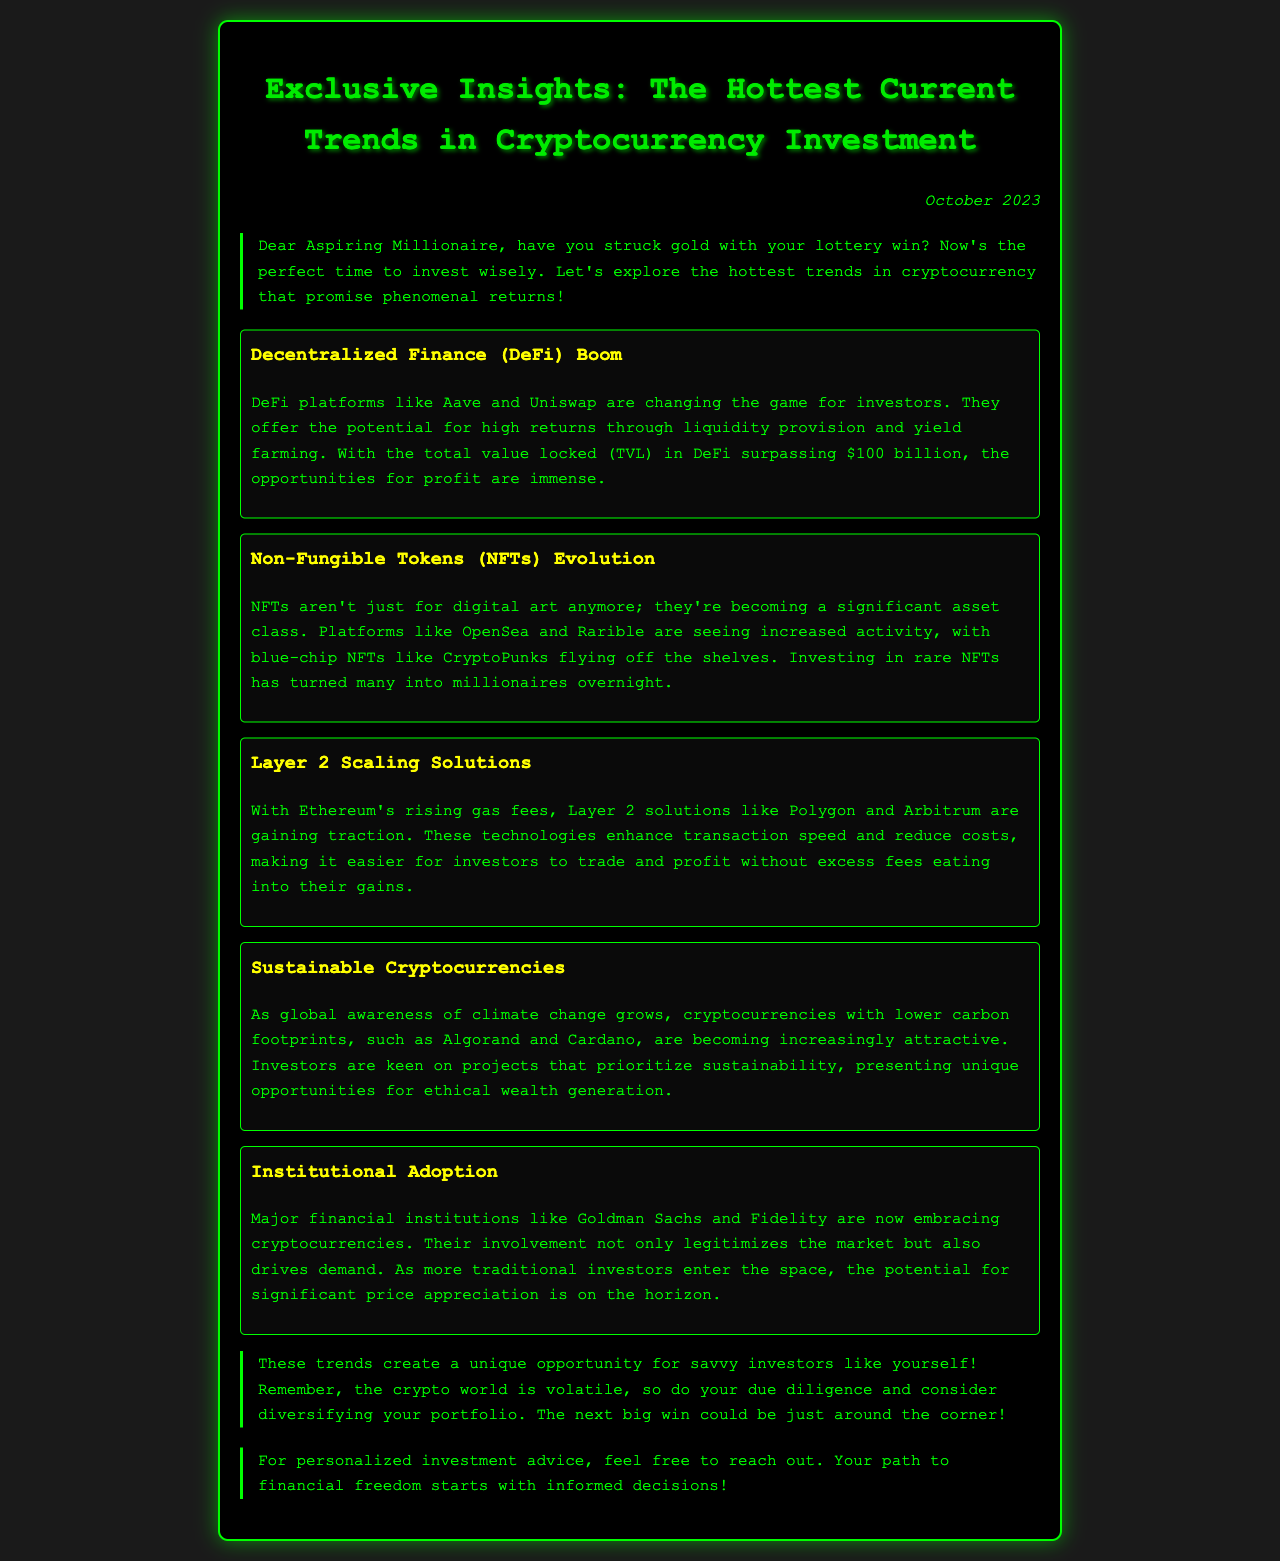What is the title of the newsletter? The title is prominently displayed at the top of the document, indicating the main focus.
Answer: Exclusive Insights: The Hottest Current Trends in Cryptocurrency Investment What is the date of publication? The date is mentioned in the upper right corner of the document.
Answer: October 2023 What percentage of TVL in DeFi is mentioned? The total value locked in DeFi is stated in the context of the trends discussed.
Answer: $100 billion Which platforms are mentioned for decentralized finance? Specific platforms are highlighted in the DeFi trend section, presenting what investors should consider.
Answer: Aave and Uniswap What are NFTs primarily becoming in addition to digital art? The document explains the evolving role of NFTs in the investment landscape.
Answer: A significant asset class Which Layer 2 solution is specifically mentioned for Ethereum? The document lists a Layer 2 solution that enhances transaction capabilities for investors.
Answer: Polygon What type of cryptocurrencies are gaining popularity related to climate change? The trends section discusses growing interest in certain cryptocurrencies based on environmental factors.
Answer: Sustainable Cryptocurrencies Which major financial institution is embracing cryptocurrencies? The text reveals institutional players that are contributing to market legitimacy and demand.
Answer: Goldman Sachs What is emphasized as important for investors in the conclusion? The conclusion offers guidance for smart investment practices.
Answer: Doing due diligence 